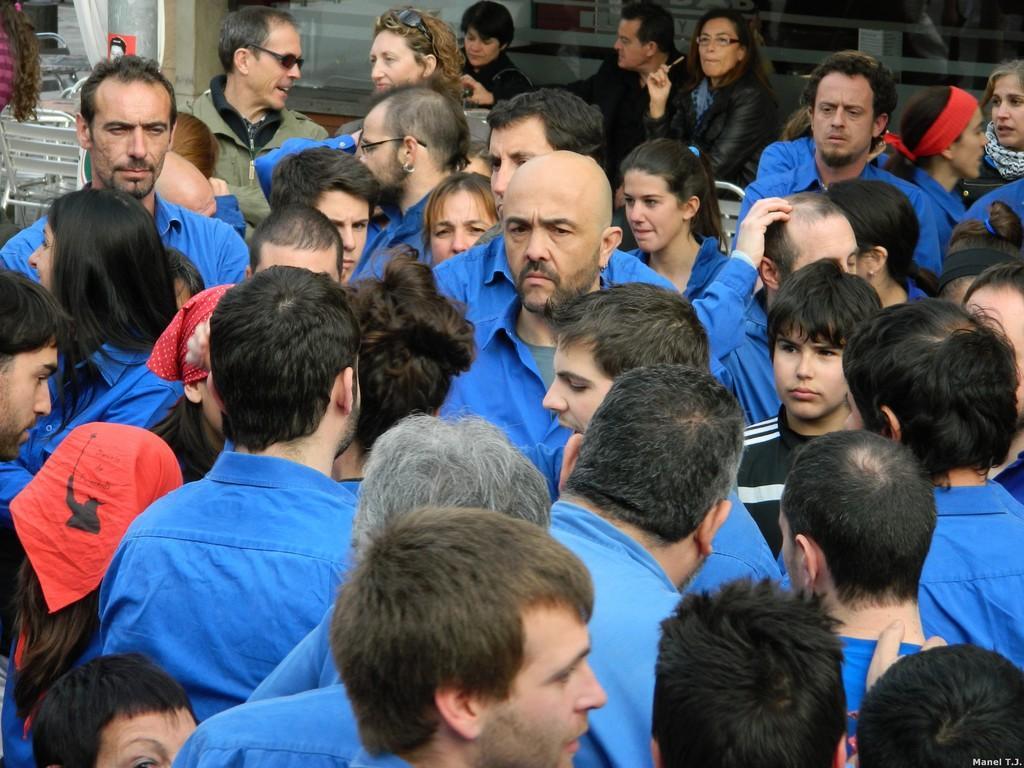In one or two sentences, can you explain what this image depicts? In the center of the image we can see a few people are standing and they are in different costumes. In the background there is a wall, glass, benches, few people are sitting and a few other objects. 